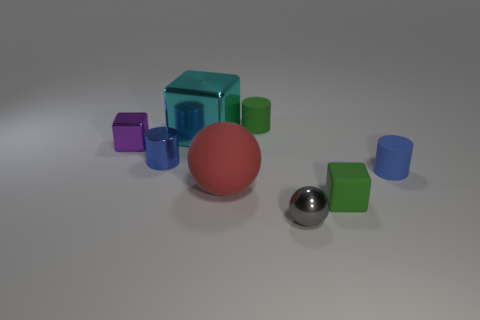Subtract all green cubes. How many cubes are left? 2 Add 2 big rubber spheres. How many objects exist? 10 Subtract all gray balls. How many balls are left? 1 Subtract 2 cylinders. How many cylinders are left? 1 Subtract all cylinders. How many objects are left? 5 Subtract 1 red balls. How many objects are left? 7 Subtract all red cubes. Subtract all gray cylinders. How many cubes are left? 3 Subtract all red blocks. How many red balls are left? 1 Subtract all tiny purple things. Subtract all tiny green metallic things. How many objects are left? 7 Add 2 purple blocks. How many purple blocks are left? 3 